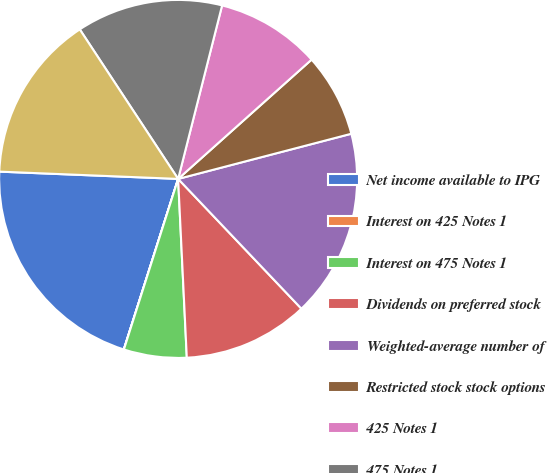Convert chart to OTSL. <chart><loc_0><loc_0><loc_500><loc_500><pie_chart><fcel>Net income available to IPG<fcel>Interest on 425 Notes 1<fcel>Interest on 475 Notes 1<fcel>Dividends on preferred stock<fcel>Weighted-average number of<fcel>Restricted stock stock options<fcel>425 Notes 1<fcel>475 Notes 1<fcel>Preferred stock outstanding 2<nl><fcel>20.74%<fcel>0.01%<fcel>5.67%<fcel>11.32%<fcel>16.97%<fcel>7.55%<fcel>9.44%<fcel>13.21%<fcel>15.09%<nl></chart> 